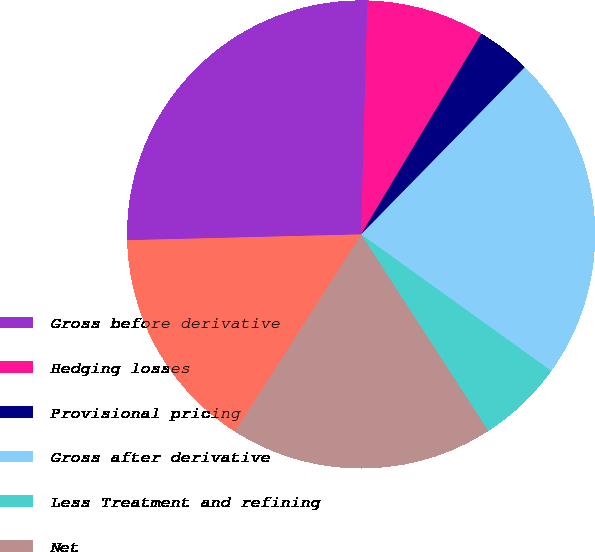Convert chart to OTSL. <chart><loc_0><loc_0><loc_500><loc_500><pie_chart><fcel>Gross before derivative<fcel>Hedging losses<fcel>Provisional pricing<fcel>Gross after derivative<fcel>Less Treatment and refining<fcel>Net<fcel>Consolidated copper pounds<nl><fcel>25.83%<fcel>8.16%<fcel>3.74%<fcel>22.58%<fcel>5.95%<fcel>18.21%<fcel>15.53%<nl></chart> 